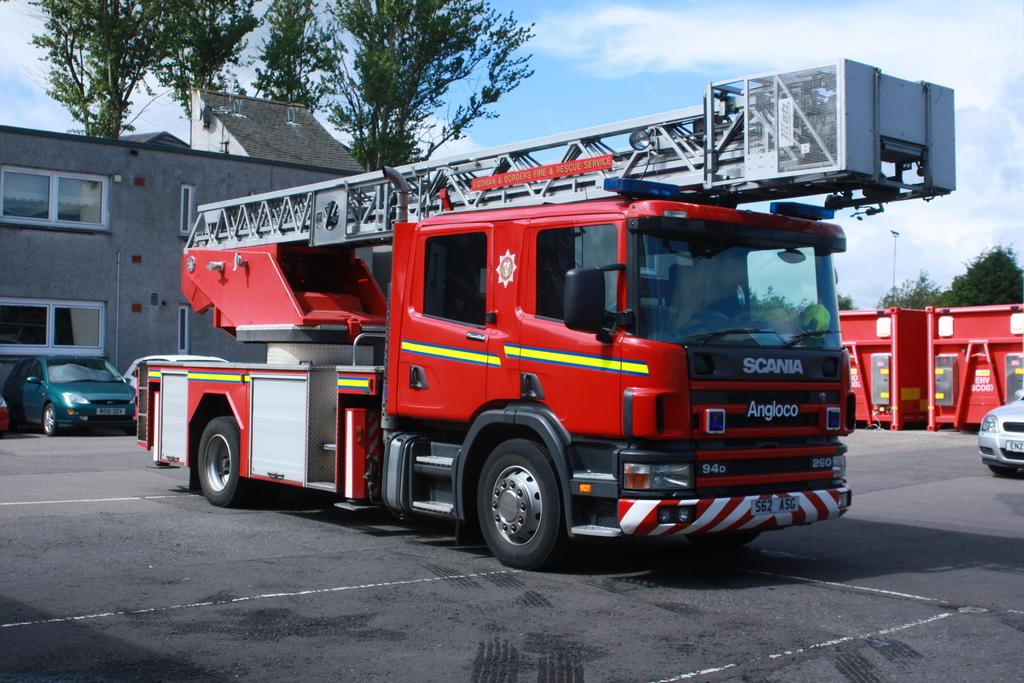What is the main subject of the image? There is a fire engine in the image. What else can be seen behind the fire engine? There are vehicles behind the fire engine. What type of structures are visible in the image? There are houses in the image. What other objects can be seen in the image? There are other objects in the image. What is visible in the background of the image? There are trees and clouds in the sky in the background of the image. Where is the rake being used in the image? There is no rake present in the image. How many bridges can be seen crossing the river in the image? There is no river or bridge present in the image. 